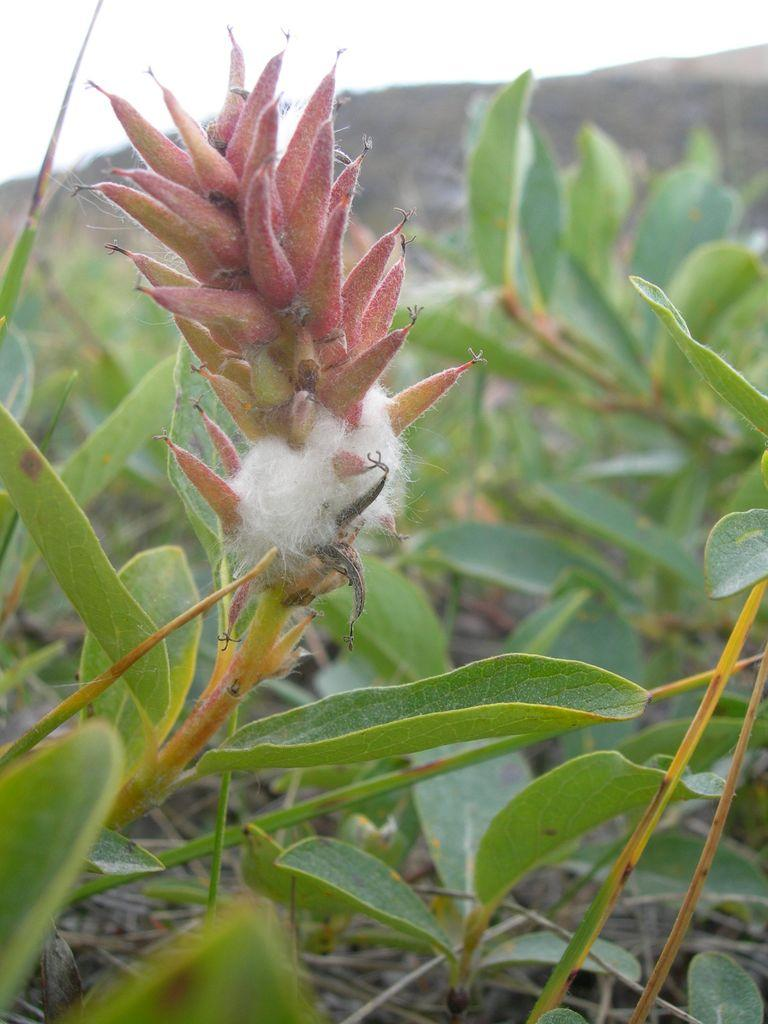What type of plant is featured in the image? There is a plant with a flower and leaves in the image. Are there any other plants visible in the image? Yes, there are other plants with leaves in the background of the image. What can be seen in the distance behind the plants? There is a hill visible in the background of the image. What is visible at the top of the image? The sky is visible at the top of the image. Where is the volleyball court located in the image? There is no volleyball court present in the image. What type of basket is hanging from the plant in the image? There is no basket hanging from the plant in the image. 